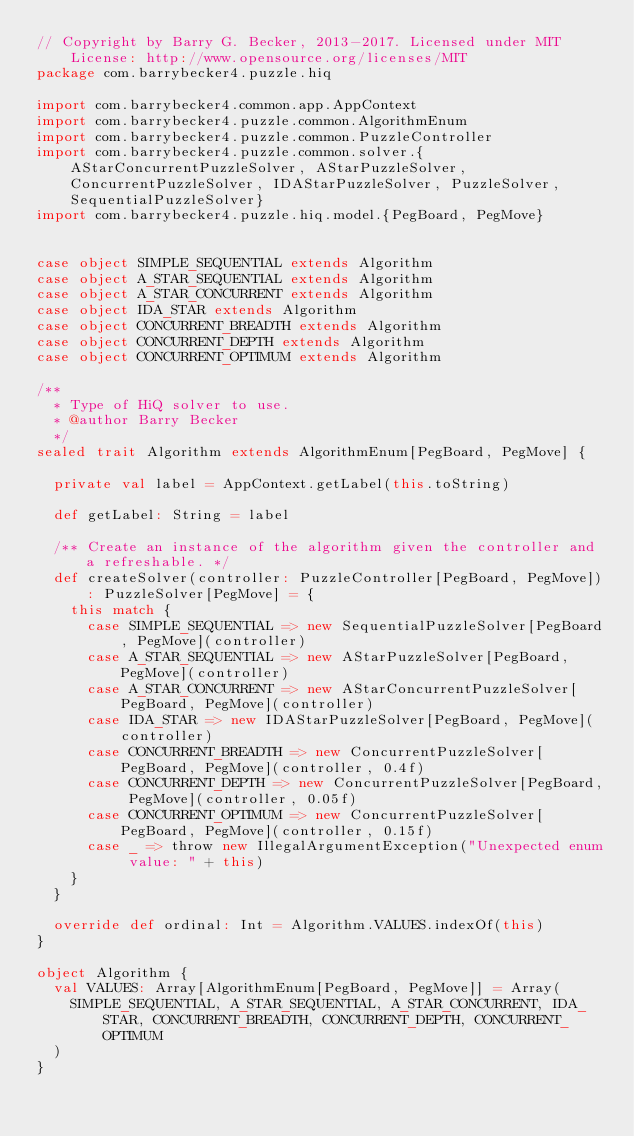Convert code to text. <code><loc_0><loc_0><loc_500><loc_500><_Scala_>// Copyright by Barry G. Becker, 2013-2017. Licensed under MIT License: http://www.opensource.org/licenses/MIT
package com.barrybecker4.puzzle.hiq

import com.barrybecker4.common.app.AppContext
import com.barrybecker4.puzzle.common.AlgorithmEnum
import com.barrybecker4.puzzle.common.PuzzleController
import com.barrybecker4.puzzle.common.solver.{AStarConcurrentPuzzleSolver, AStarPuzzleSolver, ConcurrentPuzzleSolver, IDAStarPuzzleSolver, PuzzleSolver, SequentialPuzzleSolver}
import com.barrybecker4.puzzle.hiq.model.{PegBoard, PegMove}


case object SIMPLE_SEQUENTIAL extends Algorithm
case object A_STAR_SEQUENTIAL extends Algorithm
case object A_STAR_CONCURRENT extends Algorithm
case object IDA_STAR extends Algorithm
case object CONCURRENT_BREADTH extends Algorithm
case object CONCURRENT_DEPTH extends Algorithm
case object CONCURRENT_OPTIMUM extends Algorithm

/**
  * Type of HiQ solver to use.
  * @author Barry Becker
  */
sealed trait Algorithm extends AlgorithmEnum[PegBoard, PegMove] {

  private val label = AppContext.getLabel(this.toString)

  def getLabel: String = label

  /** Create an instance of the algorithm given the controller and a refreshable. */
  def createSolver(controller: PuzzleController[PegBoard, PegMove]): PuzzleSolver[PegMove] = {
    this match {
      case SIMPLE_SEQUENTIAL => new SequentialPuzzleSolver[PegBoard, PegMove](controller)
      case A_STAR_SEQUENTIAL => new AStarPuzzleSolver[PegBoard, PegMove](controller)
      case A_STAR_CONCURRENT => new AStarConcurrentPuzzleSolver[PegBoard, PegMove](controller)
      case IDA_STAR => new IDAStarPuzzleSolver[PegBoard, PegMove](controller)
      case CONCURRENT_BREADTH => new ConcurrentPuzzleSolver[PegBoard, PegMove](controller, 0.4f)
      case CONCURRENT_DEPTH => new ConcurrentPuzzleSolver[PegBoard, PegMove](controller, 0.05f)
      case CONCURRENT_OPTIMUM => new ConcurrentPuzzleSolver[PegBoard, PegMove](controller, 0.15f)
      case _ => throw new IllegalArgumentException("Unexpected enum value: " + this)
    }
  }

  override def ordinal: Int = Algorithm.VALUES.indexOf(this)
}

object Algorithm {
  val VALUES: Array[AlgorithmEnum[PegBoard, PegMove]] = Array(
    SIMPLE_SEQUENTIAL, A_STAR_SEQUENTIAL, A_STAR_CONCURRENT, IDA_STAR, CONCURRENT_BREADTH, CONCURRENT_DEPTH, CONCURRENT_OPTIMUM
  )
}</code> 